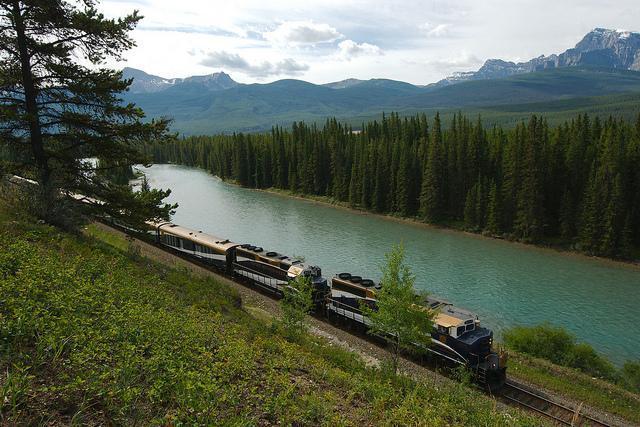How many cars are on this train?
Give a very brief answer. 6. 